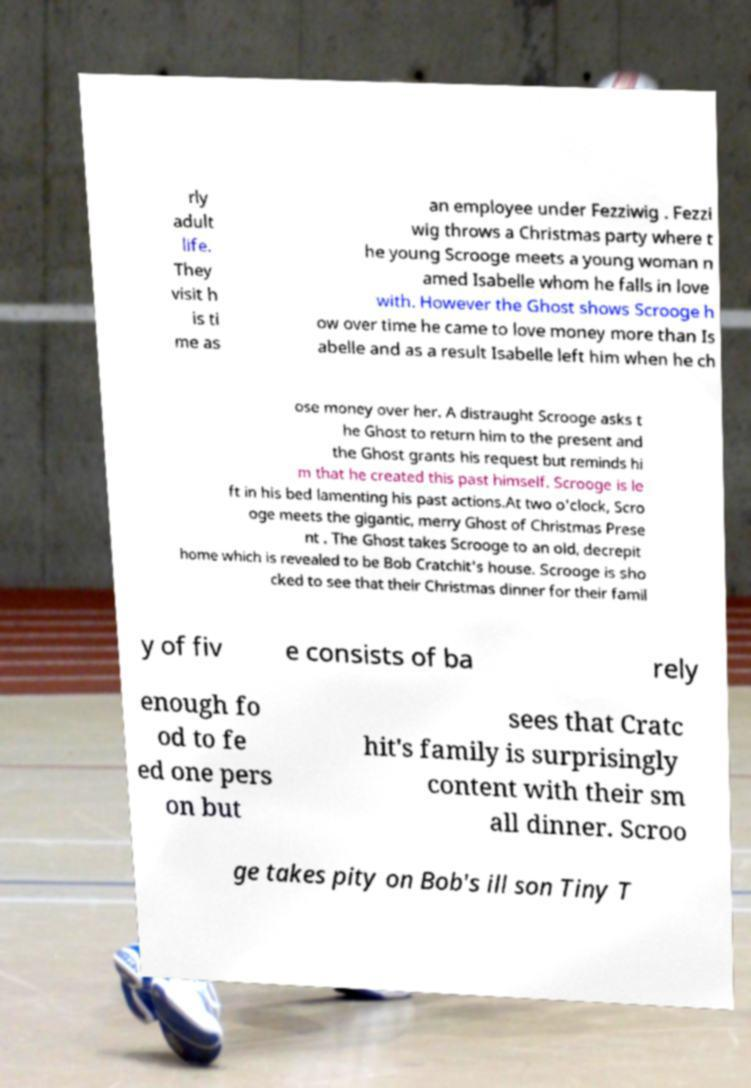Could you assist in decoding the text presented in this image and type it out clearly? rly adult life. They visit h is ti me as an employee under Fezziwig . Fezzi wig throws a Christmas party where t he young Scrooge meets a young woman n amed Isabelle whom he falls in love with. However the Ghost shows Scrooge h ow over time he came to love money more than Is abelle and as a result Isabelle left him when he ch ose money over her. A distraught Scrooge asks t he Ghost to return him to the present and the Ghost grants his request but reminds hi m that he created this past himself. Scrooge is le ft in his bed lamenting his past actions.At two o'clock, Scro oge meets the gigantic, merry Ghost of Christmas Prese nt . The Ghost takes Scrooge to an old, decrepit home which is revealed to be Bob Cratchit's house. Scrooge is sho cked to see that their Christmas dinner for their famil y of fiv e consists of ba rely enough fo od to fe ed one pers on but sees that Cratc hit's family is surprisingly content with their sm all dinner. Scroo ge takes pity on Bob's ill son Tiny T 